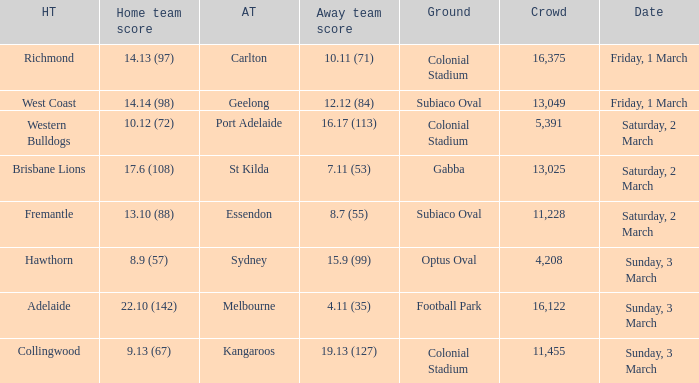What was the away team sydney's home ground? Optus Oval. 